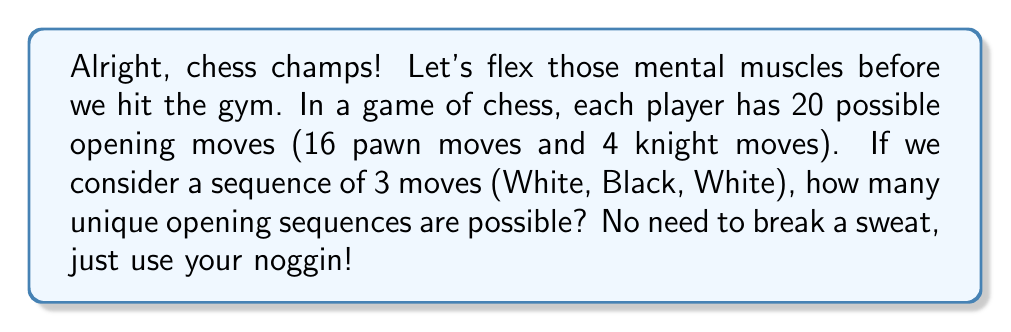Solve this math problem. Let's tackle this step-by-step, just like we approach our workout routine:

1) For the first move (White), there are 20 possible choices.

2) For the second move (Black), there are again 20 possible choices, regardless of what White chose.

3) For the third move (White), there are once more 20 possible choices, regardless of the previous moves.

4) According to the multiplication principle, when we have a sequence of independent choices, we multiply the number of possibilities for each choice.

5) Therefore, the total number of unique opening sequences is:

   $$20 \times 20 \times 20 = 20^3 = 8000$$

This is similar to how we might calculate the number of possible workout combinations if we had 20 exercises to choose from for a 3-exercise circuit!
Answer: $8000$ 